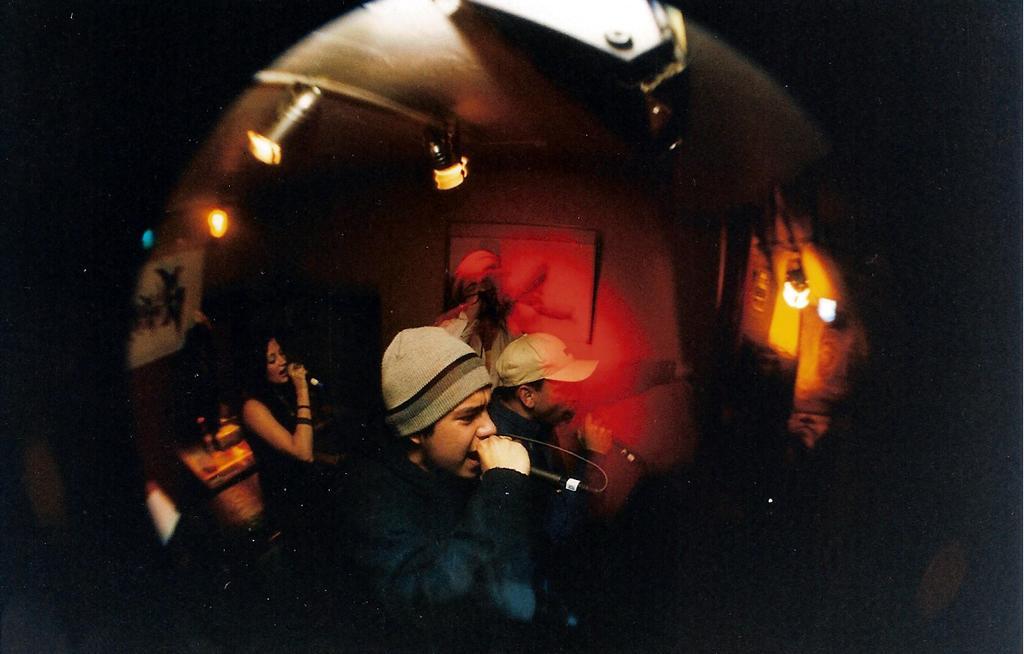Please provide a concise description of this image. In this image I can see a man is singing in the microphone, he wore coat, cap. On the left side there is a woman also doing the same, at the top there are lights. 